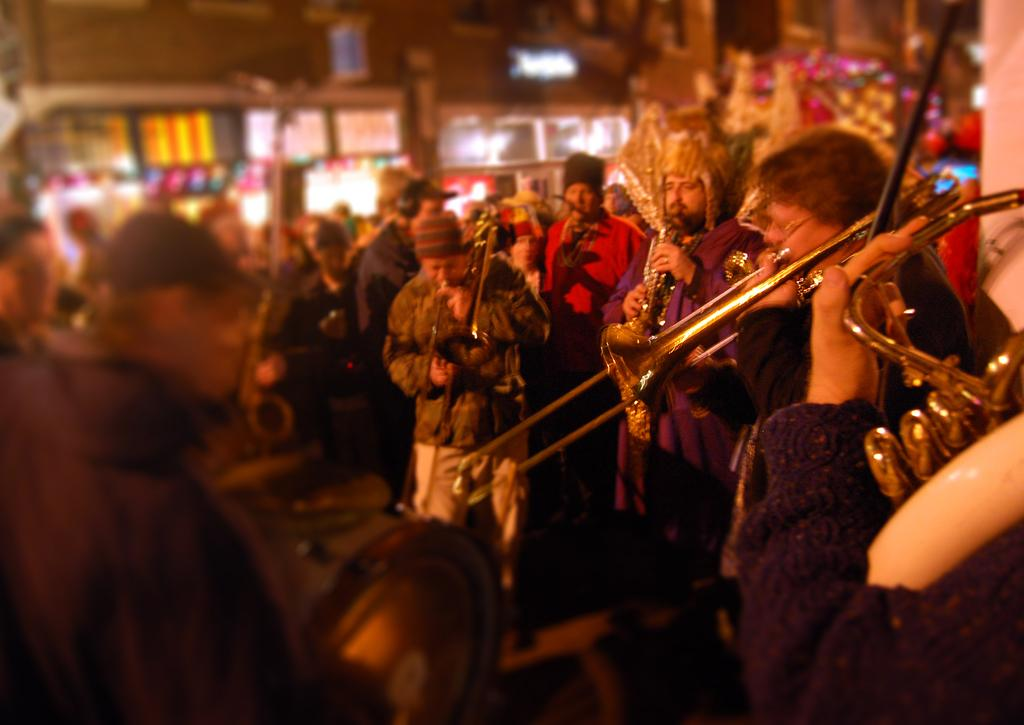What are the people in the image doing? People are playing musical instruments in the image. How would you describe the background of the image? The background is blurred in the image. What type of establishments can be seen in the image? There are stores visible in the image. What type of cable can be seen connecting the instruments in the image? There is no cable connecting the instruments visible in the image. What scientific theory is being discussed by the people playing musical instruments in the image? There is no indication in the image that the people are discussing any scientific theories. 